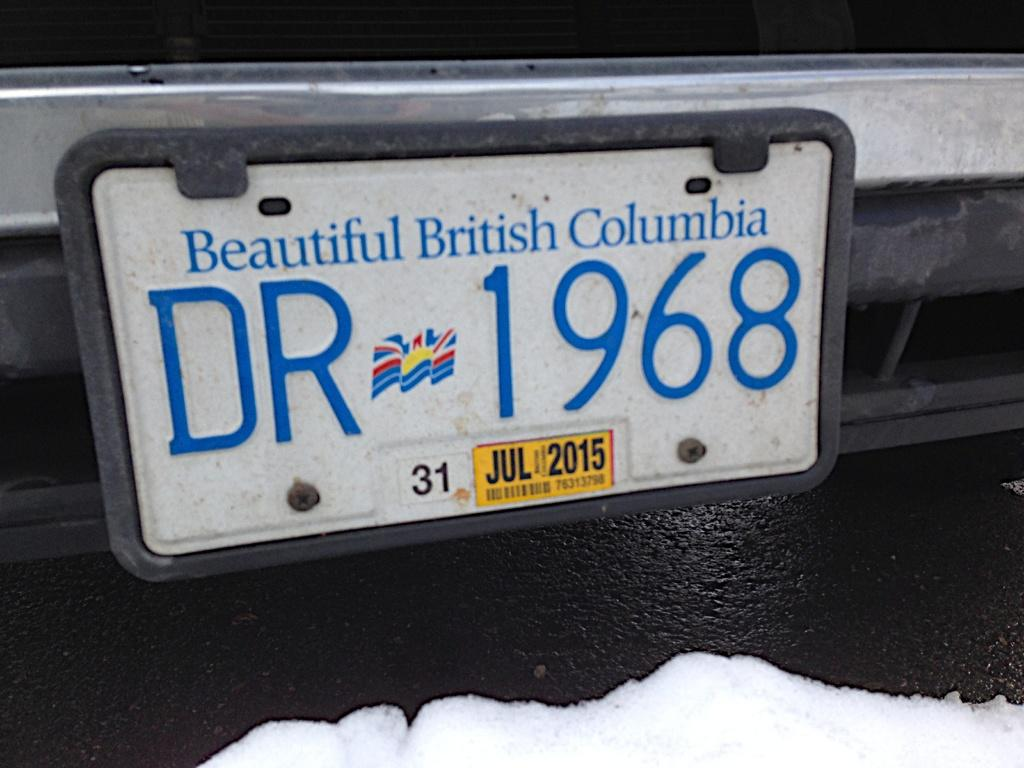Provide a one-sentence caption for the provided image. A license plate from British Columbia says DR 1968. 